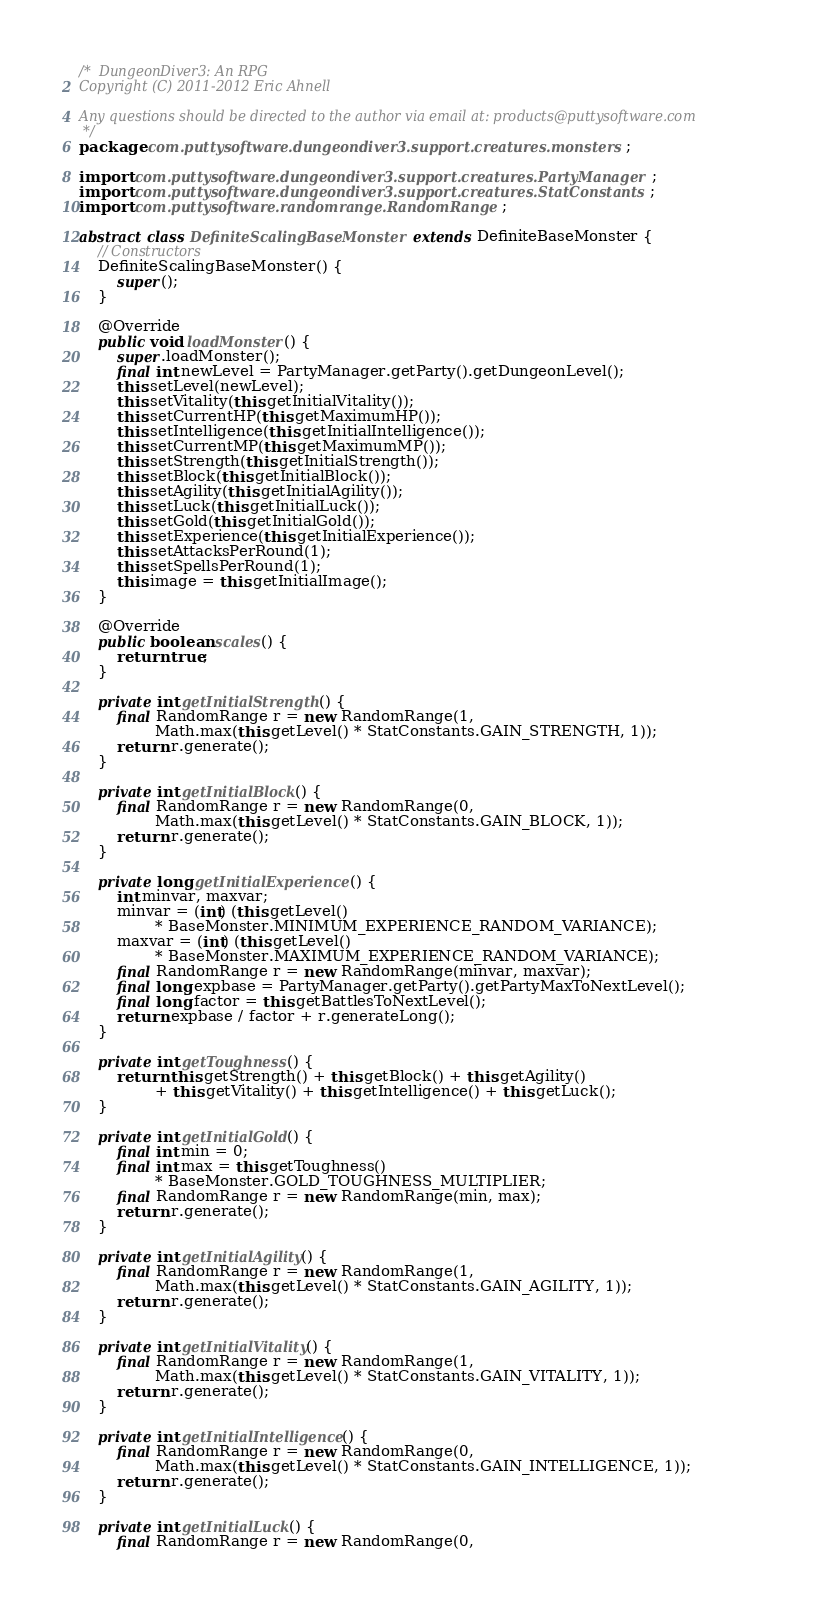Convert code to text. <code><loc_0><loc_0><loc_500><loc_500><_Java_>/*  DungeonDiver3: An RPG
Copyright (C) 2011-2012 Eric Ahnell

Any questions should be directed to the author via email at: products@puttysoftware.com
 */
package com.puttysoftware.dungeondiver3.support.creatures.monsters;

import com.puttysoftware.dungeondiver3.support.creatures.PartyManager;
import com.puttysoftware.dungeondiver3.support.creatures.StatConstants;
import com.puttysoftware.randomrange.RandomRange;

abstract class DefiniteScalingBaseMonster extends DefiniteBaseMonster {
    // Constructors
    DefiniteScalingBaseMonster() {
        super();
    }

    @Override
    public void loadMonster() {
        super.loadMonster();
        final int newLevel = PartyManager.getParty().getDungeonLevel();
        this.setLevel(newLevel);
        this.setVitality(this.getInitialVitality());
        this.setCurrentHP(this.getMaximumHP());
        this.setIntelligence(this.getInitialIntelligence());
        this.setCurrentMP(this.getMaximumMP());
        this.setStrength(this.getInitialStrength());
        this.setBlock(this.getInitialBlock());
        this.setAgility(this.getInitialAgility());
        this.setLuck(this.getInitialLuck());
        this.setGold(this.getInitialGold());
        this.setExperience(this.getInitialExperience());
        this.setAttacksPerRound(1);
        this.setSpellsPerRound(1);
        this.image = this.getInitialImage();
    }

    @Override
    public boolean scales() {
        return true;
    }

    private int getInitialStrength() {
        final RandomRange r = new RandomRange(1,
                Math.max(this.getLevel() * StatConstants.GAIN_STRENGTH, 1));
        return r.generate();
    }

    private int getInitialBlock() {
        final RandomRange r = new RandomRange(0,
                Math.max(this.getLevel() * StatConstants.GAIN_BLOCK, 1));
        return r.generate();
    }

    private long getInitialExperience() {
        int minvar, maxvar;
        minvar = (int) (this.getLevel()
                * BaseMonster.MINIMUM_EXPERIENCE_RANDOM_VARIANCE);
        maxvar = (int) (this.getLevel()
                * BaseMonster.MAXIMUM_EXPERIENCE_RANDOM_VARIANCE);
        final RandomRange r = new RandomRange(minvar, maxvar);
        final long expbase = PartyManager.getParty().getPartyMaxToNextLevel();
        final long factor = this.getBattlesToNextLevel();
        return expbase / factor + r.generateLong();
    }

    private int getToughness() {
        return this.getStrength() + this.getBlock() + this.getAgility()
                + this.getVitality() + this.getIntelligence() + this.getLuck();
    }

    private int getInitialGold() {
        final int min = 0;
        final int max = this.getToughness()
                * BaseMonster.GOLD_TOUGHNESS_MULTIPLIER;
        final RandomRange r = new RandomRange(min, max);
        return r.generate();
    }

    private int getInitialAgility() {
        final RandomRange r = new RandomRange(1,
                Math.max(this.getLevel() * StatConstants.GAIN_AGILITY, 1));
        return r.generate();
    }

    private int getInitialVitality() {
        final RandomRange r = new RandomRange(1,
                Math.max(this.getLevel() * StatConstants.GAIN_VITALITY, 1));
        return r.generate();
    }

    private int getInitialIntelligence() {
        final RandomRange r = new RandomRange(0,
                Math.max(this.getLevel() * StatConstants.GAIN_INTELLIGENCE, 1));
        return r.generate();
    }

    private int getInitialLuck() {
        final RandomRange r = new RandomRange(0,</code> 